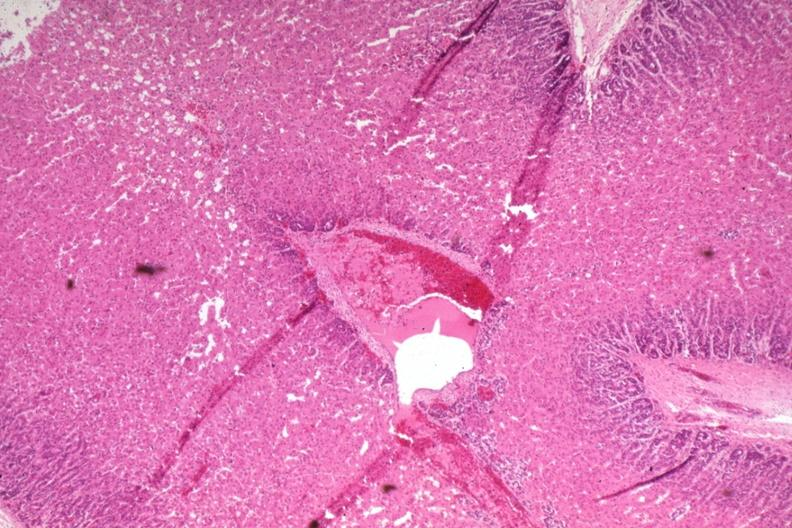s capillary present?
Answer the question using a single word or phrase. No 